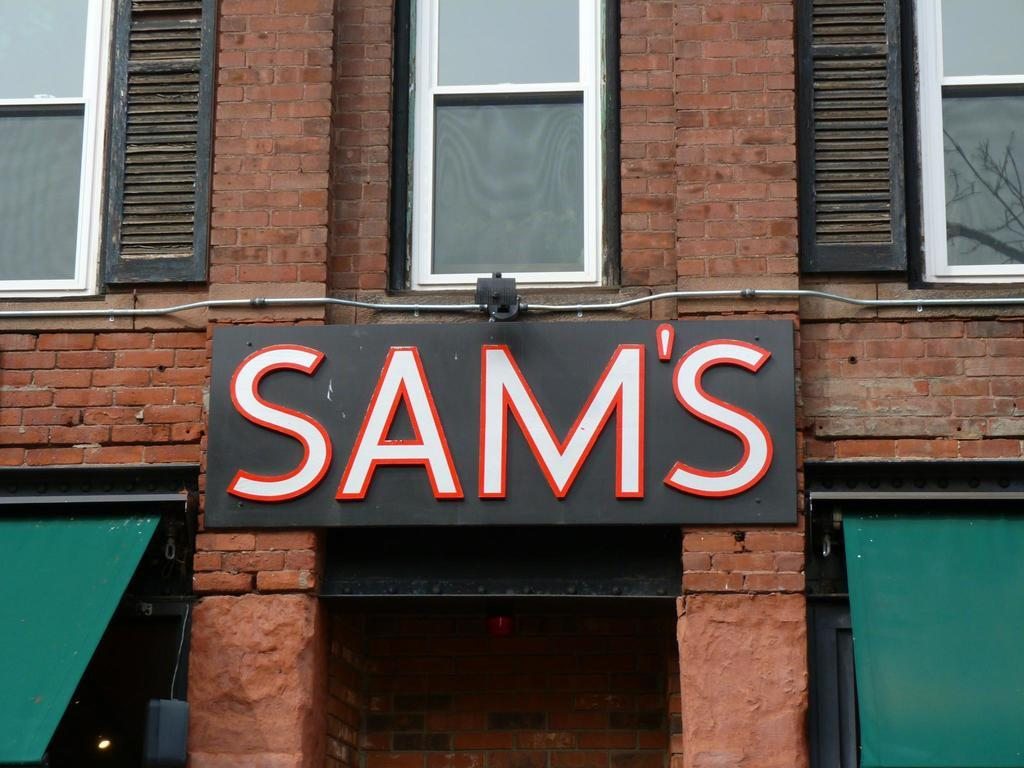Provide a one-sentence caption for the provided image. Sign stating SAM'S above a doorway between two awnings. 